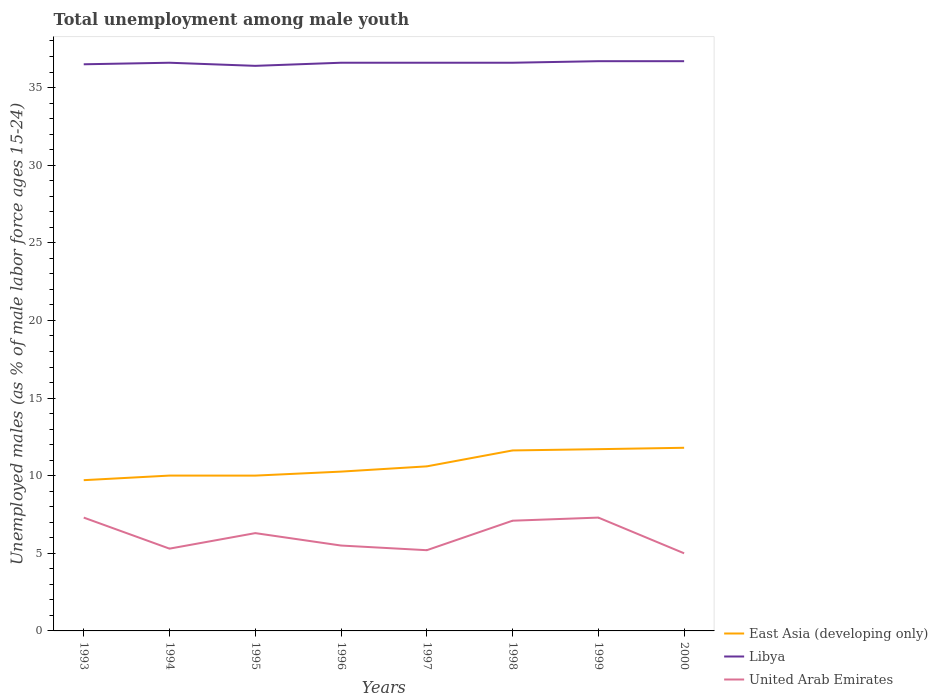Across all years, what is the maximum percentage of unemployed males in in United Arab Emirates?
Your answer should be very brief. 5. In which year was the percentage of unemployed males in in Libya maximum?
Keep it short and to the point. 1995. What is the total percentage of unemployed males in in East Asia (developing only) in the graph?
Ensure brevity in your answer.  -0.3. What is the difference between the highest and the second highest percentage of unemployed males in in United Arab Emirates?
Keep it short and to the point. 2.3. What is the difference between the highest and the lowest percentage of unemployed males in in United Arab Emirates?
Your answer should be compact. 4. Is the percentage of unemployed males in in United Arab Emirates strictly greater than the percentage of unemployed males in in East Asia (developing only) over the years?
Provide a short and direct response. Yes. How many lines are there?
Give a very brief answer. 3. How many years are there in the graph?
Provide a short and direct response. 8. Does the graph contain any zero values?
Provide a succinct answer. No. Does the graph contain grids?
Provide a succinct answer. No. How are the legend labels stacked?
Make the answer very short. Vertical. What is the title of the graph?
Give a very brief answer. Total unemployment among male youth. What is the label or title of the X-axis?
Your answer should be compact. Years. What is the label or title of the Y-axis?
Keep it short and to the point. Unemployed males (as % of male labor force ages 15-24). What is the Unemployed males (as % of male labor force ages 15-24) in East Asia (developing only) in 1993?
Keep it short and to the point. 9.71. What is the Unemployed males (as % of male labor force ages 15-24) in Libya in 1993?
Provide a short and direct response. 36.5. What is the Unemployed males (as % of male labor force ages 15-24) in United Arab Emirates in 1993?
Your answer should be very brief. 7.3. What is the Unemployed males (as % of male labor force ages 15-24) in East Asia (developing only) in 1994?
Give a very brief answer. 10.01. What is the Unemployed males (as % of male labor force ages 15-24) of Libya in 1994?
Offer a terse response. 36.6. What is the Unemployed males (as % of male labor force ages 15-24) in United Arab Emirates in 1994?
Offer a very short reply. 5.3. What is the Unemployed males (as % of male labor force ages 15-24) in East Asia (developing only) in 1995?
Provide a short and direct response. 10. What is the Unemployed males (as % of male labor force ages 15-24) in Libya in 1995?
Your answer should be very brief. 36.4. What is the Unemployed males (as % of male labor force ages 15-24) in United Arab Emirates in 1995?
Make the answer very short. 6.3. What is the Unemployed males (as % of male labor force ages 15-24) in East Asia (developing only) in 1996?
Your answer should be very brief. 10.26. What is the Unemployed males (as % of male labor force ages 15-24) in Libya in 1996?
Ensure brevity in your answer.  36.6. What is the Unemployed males (as % of male labor force ages 15-24) in United Arab Emirates in 1996?
Give a very brief answer. 5.5. What is the Unemployed males (as % of male labor force ages 15-24) of East Asia (developing only) in 1997?
Your response must be concise. 10.6. What is the Unemployed males (as % of male labor force ages 15-24) in Libya in 1997?
Keep it short and to the point. 36.6. What is the Unemployed males (as % of male labor force ages 15-24) in United Arab Emirates in 1997?
Offer a very short reply. 5.2. What is the Unemployed males (as % of male labor force ages 15-24) in East Asia (developing only) in 1998?
Provide a succinct answer. 11.63. What is the Unemployed males (as % of male labor force ages 15-24) of Libya in 1998?
Offer a very short reply. 36.6. What is the Unemployed males (as % of male labor force ages 15-24) in United Arab Emirates in 1998?
Offer a very short reply. 7.1. What is the Unemployed males (as % of male labor force ages 15-24) of East Asia (developing only) in 1999?
Ensure brevity in your answer.  11.71. What is the Unemployed males (as % of male labor force ages 15-24) in Libya in 1999?
Offer a terse response. 36.7. What is the Unemployed males (as % of male labor force ages 15-24) in United Arab Emirates in 1999?
Offer a terse response. 7.3. What is the Unemployed males (as % of male labor force ages 15-24) in East Asia (developing only) in 2000?
Give a very brief answer. 11.8. What is the Unemployed males (as % of male labor force ages 15-24) in Libya in 2000?
Give a very brief answer. 36.7. Across all years, what is the maximum Unemployed males (as % of male labor force ages 15-24) in East Asia (developing only)?
Ensure brevity in your answer.  11.8. Across all years, what is the maximum Unemployed males (as % of male labor force ages 15-24) in Libya?
Your response must be concise. 36.7. Across all years, what is the maximum Unemployed males (as % of male labor force ages 15-24) of United Arab Emirates?
Offer a very short reply. 7.3. Across all years, what is the minimum Unemployed males (as % of male labor force ages 15-24) in East Asia (developing only)?
Give a very brief answer. 9.71. Across all years, what is the minimum Unemployed males (as % of male labor force ages 15-24) of Libya?
Ensure brevity in your answer.  36.4. What is the total Unemployed males (as % of male labor force ages 15-24) in East Asia (developing only) in the graph?
Offer a terse response. 85.71. What is the total Unemployed males (as % of male labor force ages 15-24) in Libya in the graph?
Make the answer very short. 292.7. What is the difference between the Unemployed males (as % of male labor force ages 15-24) in East Asia (developing only) in 1993 and that in 1994?
Give a very brief answer. -0.3. What is the difference between the Unemployed males (as % of male labor force ages 15-24) in United Arab Emirates in 1993 and that in 1994?
Your response must be concise. 2. What is the difference between the Unemployed males (as % of male labor force ages 15-24) of East Asia (developing only) in 1993 and that in 1995?
Offer a very short reply. -0.29. What is the difference between the Unemployed males (as % of male labor force ages 15-24) in Libya in 1993 and that in 1995?
Keep it short and to the point. 0.1. What is the difference between the Unemployed males (as % of male labor force ages 15-24) of United Arab Emirates in 1993 and that in 1995?
Keep it short and to the point. 1. What is the difference between the Unemployed males (as % of male labor force ages 15-24) in East Asia (developing only) in 1993 and that in 1996?
Give a very brief answer. -0.55. What is the difference between the Unemployed males (as % of male labor force ages 15-24) of United Arab Emirates in 1993 and that in 1996?
Offer a very short reply. 1.8. What is the difference between the Unemployed males (as % of male labor force ages 15-24) in East Asia (developing only) in 1993 and that in 1997?
Offer a very short reply. -0.89. What is the difference between the Unemployed males (as % of male labor force ages 15-24) of Libya in 1993 and that in 1997?
Keep it short and to the point. -0.1. What is the difference between the Unemployed males (as % of male labor force ages 15-24) of East Asia (developing only) in 1993 and that in 1998?
Offer a terse response. -1.92. What is the difference between the Unemployed males (as % of male labor force ages 15-24) in Libya in 1993 and that in 1998?
Make the answer very short. -0.1. What is the difference between the Unemployed males (as % of male labor force ages 15-24) of East Asia (developing only) in 1993 and that in 1999?
Offer a very short reply. -2. What is the difference between the Unemployed males (as % of male labor force ages 15-24) of Libya in 1993 and that in 1999?
Offer a very short reply. -0.2. What is the difference between the Unemployed males (as % of male labor force ages 15-24) in United Arab Emirates in 1993 and that in 1999?
Provide a short and direct response. 0. What is the difference between the Unemployed males (as % of male labor force ages 15-24) in East Asia (developing only) in 1993 and that in 2000?
Keep it short and to the point. -2.09. What is the difference between the Unemployed males (as % of male labor force ages 15-24) of Libya in 1993 and that in 2000?
Make the answer very short. -0.2. What is the difference between the Unemployed males (as % of male labor force ages 15-24) of East Asia (developing only) in 1994 and that in 1995?
Make the answer very short. 0. What is the difference between the Unemployed males (as % of male labor force ages 15-24) of Libya in 1994 and that in 1995?
Offer a terse response. 0.2. What is the difference between the Unemployed males (as % of male labor force ages 15-24) of East Asia (developing only) in 1994 and that in 1996?
Your answer should be compact. -0.26. What is the difference between the Unemployed males (as % of male labor force ages 15-24) in Libya in 1994 and that in 1996?
Provide a succinct answer. 0. What is the difference between the Unemployed males (as % of male labor force ages 15-24) of United Arab Emirates in 1994 and that in 1996?
Offer a very short reply. -0.2. What is the difference between the Unemployed males (as % of male labor force ages 15-24) in East Asia (developing only) in 1994 and that in 1997?
Keep it short and to the point. -0.59. What is the difference between the Unemployed males (as % of male labor force ages 15-24) in Libya in 1994 and that in 1997?
Ensure brevity in your answer.  0. What is the difference between the Unemployed males (as % of male labor force ages 15-24) in East Asia (developing only) in 1994 and that in 1998?
Provide a short and direct response. -1.62. What is the difference between the Unemployed males (as % of male labor force ages 15-24) in East Asia (developing only) in 1994 and that in 1999?
Provide a short and direct response. -1.7. What is the difference between the Unemployed males (as % of male labor force ages 15-24) of Libya in 1994 and that in 1999?
Provide a succinct answer. -0.1. What is the difference between the Unemployed males (as % of male labor force ages 15-24) of United Arab Emirates in 1994 and that in 1999?
Provide a short and direct response. -2. What is the difference between the Unemployed males (as % of male labor force ages 15-24) of East Asia (developing only) in 1994 and that in 2000?
Provide a succinct answer. -1.79. What is the difference between the Unemployed males (as % of male labor force ages 15-24) in Libya in 1994 and that in 2000?
Give a very brief answer. -0.1. What is the difference between the Unemployed males (as % of male labor force ages 15-24) in East Asia (developing only) in 1995 and that in 1996?
Give a very brief answer. -0.26. What is the difference between the Unemployed males (as % of male labor force ages 15-24) of Libya in 1995 and that in 1996?
Offer a terse response. -0.2. What is the difference between the Unemployed males (as % of male labor force ages 15-24) of United Arab Emirates in 1995 and that in 1996?
Give a very brief answer. 0.8. What is the difference between the Unemployed males (as % of male labor force ages 15-24) in East Asia (developing only) in 1995 and that in 1997?
Provide a short and direct response. -0.6. What is the difference between the Unemployed males (as % of male labor force ages 15-24) of Libya in 1995 and that in 1997?
Your answer should be very brief. -0.2. What is the difference between the Unemployed males (as % of male labor force ages 15-24) in United Arab Emirates in 1995 and that in 1997?
Provide a succinct answer. 1.1. What is the difference between the Unemployed males (as % of male labor force ages 15-24) in East Asia (developing only) in 1995 and that in 1998?
Offer a very short reply. -1.62. What is the difference between the Unemployed males (as % of male labor force ages 15-24) of Libya in 1995 and that in 1998?
Offer a very short reply. -0.2. What is the difference between the Unemployed males (as % of male labor force ages 15-24) in United Arab Emirates in 1995 and that in 1998?
Provide a succinct answer. -0.8. What is the difference between the Unemployed males (as % of male labor force ages 15-24) of East Asia (developing only) in 1995 and that in 1999?
Make the answer very short. -1.7. What is the difference between the Unemployed males (as % of male labor force ages 15-24) of United Arab Emirates in 1995 and that in 1999?
Offer a very short reply. -1. What is the difference between the Unemployed males (as % of male labor force ages 15-24) of East Asia (developing only) in 1995 and that in 2000?
Offer a very short reply. -1.79. What is the difference between the Unemployed males (as % of male labor force ages 15-24) in Libya in 1995 and that in 2000?
Your answer should be compact. -0.3. What is the difference between the Unemployed males (as % of male labor force ages 15-24) of East Asia (developing only) in 1996 and that in 1997?
Ensure brevity in your answer.  -0.34. What is the difference between the Unemployed males (as % of male labor force ages 15-24) in Libya in 1996 and that in 1997?
Offer a terse response. 0. What is the difference between the Unemployed males (as % of male labor force ages 15-24) in East Asia (developing only) in 1996 and that in 1998?
Keep it short and to the point. -1.36. What is the difference between the Unemployed males (as % of male labor force ages 15-24) of Libya in 1996 and that in 1998?
Your response must be concise. 0. What is the difference between the Unemployed males (as % of male labor force ages 15-24) of United Arab Emirates in 1996 and that in 1998?
Keep it short and to the point. -1.6. What is the difference between the Unemployed males (as % of male labor force ages 15-24) in East Asia (developing only) in 1996 and that in 1999?
Your answer should be very brief. -1.44. What is the difference between the Unemployed males (as % of male labor force ages 15-24) of Libya in 1996 and that in 1999?
Your response must be concise. -0.1. What is the difference between the Unemployed males (as % of male labor force ages 15-24) of United Arab Emirates in 1996 and that in 1999?
Offer a terse response. -1.8. What is the difference between the Unemployed males (as % of male labor force ages 15-24) of East Asia (developing only) in 1996 and that in 2000?
Give a very brief answer. -1.53. What is the difference between the Unemployed males (as % of male labor force ages 15-24) in Libya in 1996 and that in 2000?
Your response must be concise. -0.1. What is the difference between the Unemployed males (as % of male labor force ages 15-24) of United Arab Emirates in 1996 and that in 2000?
Offer a terse response. 0.5. What is the difference between the Unemployed males (as % of male labor force ages 15-24) of East Asia (developing only) in 1997 and that in 1998?
Keep it short and to the point. -1.03. What is the difference between the Unemployed males (as % of male labor force ages 15-24) of East Asia (developing only) in 1997 and that in 1999?
Keep it short and to the point. -1.11. What is the difference between the Unemployed males (as % of male labor force ages 15-24) of Libya in 1997 and that in 1999?
Provide a succinct answer. -0.1. What is the difference between the Unemployed males (as % of male labor force ages 15-24) in East Asia (developing only) in 1997 and that in 2000?
Keep it short and to the point. -1.2. What is the difference between the Unemployed males (as % of male labor force ages 15-24) in East Asia (developing only) in 1998 and that in 1999?
Offer a terse response. -0.08. What is the difference between the Unemployed males (as % of male labor force ages 15-24) of East Asia (developing only) in 1998 and that in 2000?
Give a very brief answer. -0.17. What is the difference between the Unemployed males (as % of male labor force ages 15-24) in East Asia (developing only) in 1999 and that in 2000?
Your answer should be compact. -0.09. What is the difference between the Unemployed males (as % of male labor force ages 15-24) in Libya in 1999 and that in 2000?
Offer a very short reply. 0. What is the difference between the Unemployed males (as % of male labor force ages 15-24) in East Asia (developing only) in 1993 and the Unemployed males (as % of male labor force ages 15-24) in Libya in 1994?
Offer a terse response. -26.89. What is the difference between the Unemployed males (as % of male labor force ages 15-24) in East Asia (developing only) in 1993 and the Unemployed males (as % of male labor force ages 15-24) in United Arab Emirates in 1994?
Provide a short and direct response. 4.41. What is the difference between the Unemployed males (as % of male labor force ages 15-24) in Libya in 1993 and the Unemployed males (as % of male labor force ages 15-24) in United Arab Emirates in 1994?
Offer a very short reply. 31.2. What is the difference between the Unemployed males (as % of male labor force ages 15-24) of East Asia (developing only) in 1993 and the Unemployed males (as % of male labor force ages 15-24) of Libya in 1995?
Provide a short and direct response. -26.69. What is the difference between the Unemployed males (as % of male labor force ages 15-24) in East Asia (developing only) in 1993 and the Unemployed males (as % of male labor force ages 15-24) in United Arab Emirates in 1995?
Your answer should be compact. 3.41. What is the difference between the Unemployed males (as % of male labor force ages 15-24) in Libya in 1993 and the Unemployed males (as % of male labor force ages 15-24) in United Arab Emirates in 1995?
Your answer should be very brief. 30.2. What is the difference between the Unemployed males (as % of male labor force ages 15-24) in East Asia (developing only) in 1993 and the Unemployed males (as % of male labor force ages 15-24) in Libya in 1996?
Your answer should be very brief. -26.89. What is the difference between the Unemployed males (as % of male labor force ages 15-24) of East Asia (developing only) in 1993 and the Unemployed males (as % of male labor force ages 15-24) of United Arab Emirates in 1996?
Offer a very short reply. 4.21. What is the difference between the Unemployed males (as % of male labor force ages 15-24) in East Asia (developing only) in 1993 and the Unemployed males (as % of male labor force ages 15-24) in Libya in 1997?
Your answer should be very brief. -26.89. What is the difference between the Unemployed males (as % of male labor force ages 15-24) of East Asia (developing only) in 1993 and the Unemployed males (as % of male labor force ages 15-24) of United Arab Emirates in 1997?
Ensure brevity in your answer.  4.51. What is the difference between the Unemployed males (as % of male labor force ages 15-24) in Libya in 1993 and the Unemployed males (as % of male labor force ages 15-24) in United Arab Emirates in 1997?
Offer a very short reply. 31.3. What is the difference between the Unemployed males (as % of male labor force ages 15-24) of East Asia (developing only) in 1993 and the Unemployed males (as % of male labor force ages 15-24) of Libya in 1998?
Ensure brevity in your answer.  -26.89. What is the difference between the Unemployed males (as % of male labor force ages 15-24) of East Asia (developing only) in 1993 and the Unemployed males (as % of male labor force ages 15-24) of United Arab Emirates in 1998?
Provide a short and direct response. 2.61. What is the difference between the Unemployed males (as % of male labor force ages 15-24) in Libya in 1993 and the Unemployed males (as % of male labor force ages 15-24) in United Arab Emirates in 1998?
Your answer should be very brief. 29.4. What is the difference between the Unemployed males (as % of male labor force ages 15-24) in East Asia (developing only) in 1993 and the Unemployed males (as % of male labor force ages 15-24) in Libya in 1999?
Keep it short and to the point. -26.99. What is the difference between the Unemployed males (as % of male labor force ages 15-24) of East Asia (developing only) in 1993 and the Unemployed males (as % of male labor force ages 15-24) of United Arab Emirates in 1999?
Ensure brevity in your answer.  2.41. What is the difference between the Unemployed males (as % of male labor force ages 15-24) in Libya in 1993 and the Unemployed males (as % of male labor force ages 15-24) in United Arab Emirates in 1999?
Make the answer very short. 29.2. What is the difference between the Unemployed males (as % of male labor force ages 15-24) of East Asia (developing only) in 1993 and the Unemployed males (as % of male labor force ages 15-24) of Libya in 2000?
Keep it short and to the point. -26.99. What is the difference between the Unemployed males (as % of male labor force ages 15-24) in East Asia (developing only) in 1993 and the Unemployed males (as % of male labor force ages 15-24) in United Arab Emirates in 2000?
Give a very brief answer. 4.71. What is the difference between the Unemployed males (as % of male labor force ages 15-24) in Libya in 1993 and the Unemployed males (as % of male labor force ages 15-24) in United Arab Emirates in 2000?
Make the answer very short. 31.5. What is the difference between the Unemployed males (as % of male labor force ages 15-24) in East Asia (developing only) in 1994 and the Unemployed males (as % of male labor force ages 15-24) in Libya in 1995?
Offer a very short reply. -26.39. What is the difference between the Unemployed males (as % of male labor force ages 15-24) in East Asia (developing only) in 1994 and the Unemployed males (as % of male labor force ages 15-24) in United Arab Emirates in 1995?
Make the answer very short. 3.71. What is the difference between the Unemployed males (as % of male labor force ages 15-24) in Libya in 1994 and the Unemployed males (as % of male labor force ages 15-24) in United Arab Emirates in 1995?
Provide a succinct answer. 30.3. What is the difference between the Unemployed males (as % of male labor force ages 15-24) in East Asia (developing only) in 1994 and the Unemployed males (as % of male labor force ages 15-24) in Libya in 1996?
Your answer should be very brief. -26.59. What is the difference between the Unemployed males (as % of male labor force ages 15-24) of East Asia (developing only) in 1994 and the Unemployed males (as % of male labor force ages 15-24) of United Arab Emirates in 1996?
Offer a very short reply. 4.51. What is the difference between the Unemployed males (as % of male labor force ages 15-24) in Libya in 1994 and the Unemployed males (as % of male labor force ages 15-24) in United Arab Emirates in 1996?
Make the answer very short. 31.1. What is the difference between the Unemployed males (as % of male labor force ages 15-24) of East Asia (developing only) in 1994 and the Unemployed males (as % of male labor force ages 15-24) of Libya in 1997?
Provide a short and direct response. -26.59. What is the difference between the Unemployed males (as % of male labor force ages 15-24) in East Asia (developing only) in 1994 and the Unemployed males (as % of male labor force ages 15-24) in United Arab Emirates in 1997?
Offer a terse response. 4.81. What is the difference between the Unemployed males (as % of male labor force ages 15-24) in Libya in 1994 and the Unemployed males (as % of male labor force ages 15-24) in United Arab Emirates in 1997?
Give a very brief answer. 31.4. What is the difference between the Unemployed males (as % of male labor force ages 15-24) in East Asia (developing only) in 1994 and the Unemployed males (as % of male labor force ages 15-24) in Libya in 1998?
Provide a short and direct response. -26.59. What is the difference between the Unemployed males (as % of male labor force ages 15-24) in East Asia (developing only) in 1994 and the Unemployed males (as % of male labor force ages 15-24) in United Arab Emirates in 1998?
Your answer should be very brief. 2.91. What is the difference between the Unemployed males (as % of male labor force ages 15-24) of Libya in 1994 and the Unemployed males (as % of male labor force ages 15-24) of United Arab Emirates in 1998?
Provide a succinct answer. 29.5. What is the difference between the Unemployed males (as % of male labor force ages 15-24) in East Asia (developing only) in 1994 and the Unemployed males (as % of male labor force ages 15-24) in Libya in 1999?
Your answer should be very brief. -26.69. What is the difference between the Unemployed males (as % of male labor force ages 15-24) in East Asia (developing only) in 1994 and the Unemployed males (as % of male labor force ages 15-24) in United Arab Emirates in 1999?
Make the answer very short. 2.71. What is the difference between the Unemployed males (as % of male labor force ages 15-24) in Libya in 1994 and the Unemployed males (as % of male labor force ages 15-24) in United Arab Emirates in 1999?
Offer a terse response. 29.3. What is the difference between the Unemployed males (as % of male labor force ages 15-24) of East Asia (developing only) in 1994 and the Unemployed males (as % of male labor force ages 15-24) of Libya in 2000?
Offer a terse response. -26.69. What is the difference between the Unemployed males (as % of male labor force ages 15-24) of East Asia (developing only) in 1994 and the Unemployed males (as % of male labor force ages 15-24) of United Arab Emirates in 2000?
Offer a terse response. 5.01. What is the difference between the Unemployed males (as % of male labor force ages 15-24) of Libya in 1994 and the Unemployed males (as % of male labor force ages 15-24) of United Arab Emirates in 2000?
Ensure brevity in your answer.  31.6. What is the difference between the Unemployed males (as % of male labor force ages 15-24) of East Asia (developing only) in 1995 and the Unemployed males (as % of male labor force ages 15-24) of Libya in 1996?
Give a very brief answer. -26.6. What is the difference between the Unemployed males (as % of male labor force ages 15-24) in East Asia (developing only) in 1995 and the Unemployed males (as % of male labor force ages 15-24) in United Arab Emirates in 1996?
Keep it short and to the point. 4.5. What is the difference between the Unemployed males (as % of male labor force ages 15-24) in Libya in 1995 and the Unemployed males (as % of male labor force ages 15-24) in United Arab Emirates in 1996?
Ensure brevity in your answer.  30.9. What is the difference between the Unemployed males (as % of male labor force ages 15-24) in East Asia (developing only) in 1995 and the Unemployed males (as % of male labor force ages 15-24) in Libya in 1997?
Offer a terse response. -26.6. What is the difference between the Unemployed males (as % of male labor force ages 15-24) in East Asia (developing only) in 1995 and the Unemployed males (as % of male labor force ages 15-24) in United Arab Emirates in 1997?
Your answer should be very brief. 4.8. What is the difference between the Unemployed males (as % of male labor force ages 15-24) in Libya in 1995 and the Unemployed males (as % of male labor force ages 15-24) in United Arab Emirates in 1997?
Your response must be concise. 31.2. What is the difference between the Unemployed males (as % of male labor force ages 15-24) in East Asia (developing only) in 1995 and the Unemployed males (as % of male labor force ages 15-24) in Libya in 1998?
Give a very brief answer. -26.6. What is the difference between the Unemployed males (as % of male labor force ages 15-24) in East Asia (developing only) in 1995 and the Unemployed males (as % of male labor force ages 15-24) in United Arab Emirates in 1998?
Make the answer very short. 2.9. What is the difference between the Unemployed males (as % of male labor force ages 15-24) of Libya in 1995 and the Unemployed males (as % of male labor force ages 15-24) of United Arab Emirates in 1998?
Your answer should be very brief. 29.3. What is the difference between the Unemployed males (as % of male labor force ages 15-24) in East Asia (developing only) in 1995 and the Unemployed males (as % of male labor force ages 15-24) in Libya in 1999?
Your answer should be very brief. -26.7. What is the difference between the Unemployed males (as % of male labor force ages 15-24) in East Asia (developing only) in 1995 and the Unemployed males (as % of male labor force ages 15-24) in United Arab Emirates in 1999?
Your answer should be compact. 2.7. What is the difference between the Unemployed males (as % of male labor force ages 15-24) in Libya in 1995 and the Unemployed males (as % of male labor force ages 15-24) in United Arab Emirates in 1999?
Your answer should be compact. 29.1. What is the difference between the Unemployed males (as % of male labor force ages 15-24) of East Asia (developing only) in 1995 and the Unemployed males (as % of male labor force ages 15-24) of Libya in 2000?
Your response must be concise. -26.7. What is the difference between the Unemployed males (as % of male labor force ages 15-24) of East Asia (developing only) in 1995 and the Unemployed males (as % of male labor force ages 15-24) of United Arab Emirates in 2000?
Provide a short and direct response. 5. What is the difference between the Unemployed males (as % of male labor force ages 15-24) of Libya in 1995 and the Unemployed males (as % of male labor force ages 15-24) of United Arab Emirates in 2000?
Keep it short and to the point. 31.4. What is the difference between the Unemployed males (as % of male labor force ages 15-24) in East Asia (developing only) in 1996 and the Unemployed males (as % of male labor force ages 15-24) in Libya in 1997?
Your answer should be compact. -26.34. What is the difference between the Unemployed males (as % of male labor force ages 15-24) of East Asia (developing only) in 1996 and the Unemployed males (as % of male labor force ages 15-24) of United Arab Emirates in 1997?
Offer a terse response. 5.06. What is the difference between the Unemployed males (as % of male labor force ages 15-24) of Libya in 1996 and the Unemployed males (as % of male labor force ages 15-24) of United Arab Emirates in 1997?
Your answer should be very brief. 31.4. What is the difference between the Unemployed males (as % of male labor force ages 15-24) of East Asia (developing only) in 1996 and the Unemployed males (as % of male labor force ages 15-24) of Libya in 1998?
Your answer should be compact. -26.34. What is the difference between the Unemployed males (as % of male labor force ages 15-24) in East Asia (developing only) in 1996 and the Unemployed males (as % of male labor force ages 15-24) in United Arab Emirates in 1998?
Your answer should be very brief. 3.16. What is the difference between the Unemployed males (as % of male labor force ages 15-24) in Libya in 1996 and the Unemployed males (as % of male labor force ages 15-24) in United Arab Emirates in 1998?
Offer a very short reply. 29.5. What is the difference between the Unemployed males (as % of male labor force ages 15-24) in East Asia (developing only) in 1996 and the Unemployed males (as % of male labor force ages 15-24) in Libya in 1999?
Offer a terse response. -26.44. What is the difference between the Unemployed males (as % of male labor force ages 15-24) of East Asia (developing only) in 1996 and the Unemployed males (as % of male labor force ages 15-24) of United Arab Emirates in 1999?
Make the answer very short. 2.96. What is the difference between the Unemployed males (as % of male labor force ages 15-24) of Libya in 1996 and the Unemployed males (as % of male labor force ages 15-24) of United Arab Emirates in 1999?
Give a very brief answer. 29.3. What is the difference between the Unemployed males (as % of male labor force ages 15-24) of East Asia (developing only) in 1996 and the Unemployed males (as % of male labor force ages 15-24) of Libya in 2000?
Offer a very short reply. -26.44. What is the difference between the Unemployed males (as % of male labor force ages 15-24) of East Asia (developing only) in 1996 and the Unemployed males (as % of male labor force ages 15-24) of United Arab Emirates in 2000?
Keep it short and to the point. 5.26. What is the difference between the Unemployed males (as % of male labor force ages 15-24) in Libya in 1996 and the Unemployed males (as % of male labor force ages 15-24) in United Arab Emirates in 2000?
Offer a very short reply. 31.6. What is the difference between the Unemployed males (as % of male labor force ages 15-24) in East Asia (developing only) in 1997 and the Unemployed males (as % of male labor force ages 15-24) in Libya in 1998?
Give a very brief answer. -26. What is the difference between the Unemployed males (as % of male labor force ages 15-24) of East Asia (developing only) in 1997 and the Unemployed males (as % of male labor force ages 15-24) of United Arab Emirates in 1998?
Provide a succinct answer. 3.5. What is the difference between the Unemployed males (as % of male labor force ages 15-24) of Libya in 1997 and the Unemployed males (as % of male labor force ages 15-24) of United Arab Emirates in 1998?
Provide a succinct answer. 29.5. What is the difference between the Unemployed males (as % of male labor force ages 15-24) of East Asia (developing only) in 1997 and the Unemployed males (as % of male labor force ages 15-24) of Libya in 1999?
Offer a very short reply. -26.1. What is the difference between the Unemployed males (as % of male labor force ages 15-24) in East Asia (developing only) in 1997 and the Unemployed males (as % of male labor force ages 15-24) in United Arab Emirates in 1999?
Your answer should be compact. 3.3. What is the difference between the Unemployed males (as % of male labor force ages 15-24) of Libya in 1997 and the Unemployed males (as % of male labor force ages 15-24) of United Arab Emirates in 1999?
Your answer should be compact. 29.3. What is the difference between the Unemployed males (as % of male labor force ages 15-24) in East Asia (developing only) in 1997 and the Unemployed males (as % of male labor force ages 15-24) in Libya in 2000?
Provide a succinct answer. -26.1. What is the difference between the Unemployed males (as % of male labor force ages 15-24) of East Asia (developing only) in 1997 and the Unemployed males (as % of male labor force ages 15-24) of United Arab Emirates in 2000?
Offer a terse response. 5.6. What is the difference between the Unemployed males (as % of male labor force ages 15-24) of Libya in 1997 and the Unemployed males (as % of male labor force ages 15-24) of United Arab Emirates in 2000?
Offer a very short reply. 31.6. What is the difference between the Unemployed males (as % of male labor force ages 15-24) in East Asia (developing only) in 1998 and the Unemployed males (as % of male labor force ages 15-24) in Libya in 1999?
Provide a short and direct response. -25.07. What is the difference between the Unemployed males (as % of male labor force ages 15-24) of East Asia (developing only) in 1998 and the Unemployed males (as % of male labor force ages 15-24) of United Arab Emirates in 1999?
Keep it short and to the point. 4.33. What is the difference between the Unemployed males (as % of male labor force ages 15-24) of Libya in 1998 and the Unemployed males (as % of male labor force ages 15-24) of United Arab Emirates in 1999?
Provide a short and direct response. 29.3. What is the difference between the Unemployed males (as % of male labor force ages 15-24) in East Asia (developing only) in 1998 and the Unemployed males (as % of male labor force ages 15-24) in Libya in 2000?
Ensure brevity in your answer.  -25.07. What is the difference between the Unemployed males (as % of male labor force ages 15-24) in East Asia (developing only) in 1998 and the Unemployed males (as % of male labor force ages 15-24) in United Arab Emirates in 2000?
Your answer should be very brief. 6.63. What is the difference between the Unemployed males (as % of male labor force ages 15-24) in Libya in 1998 and the Unemployed males (as % of male labor force ages 15-24) in United Arab Emirates in 2000?
Your answer should be very brief. 31.6. What is the difference between the Unemployed males (as % of male labor force ages 15-24) of East Asia (developing only) in 1999 and the Unemployed males (as % of male labor force ages 15-24) of Libya in 2000?
Provide a succinct answer. -24.99. What is the difference between the Unemployed males (as % of male labor force ages 15-24) in East Asia (developing only) in 1999 and the Unemployed males (as % of male labor force ages 15-24) in United Arab Emirates in 2000?
Keep it short and to the point. 6.71. What is the difference between the Unemployed males (as % of male labor force ages 15-24) of Libya in 1999 and the Unemployed males (as % of male labor force ages 15-24) of United Arab Emirates in 2000?
Your answer should be compact. 31.7. What is the average Unemployed males (as % of male labor force ages 15-24) of East Asia (developing only) per year?
Your answer should be very brief. 10.71. What is the average Unemployed males (as % of male labor force ages 15-24) of Libya per year?
Your answer should be very brief. 36.59. What is the average Unemployed males (as % of male labor force ages 15-24) of United Arab Emirates per year?
Provide a short and direct response. 6.12. In the year 1993, what is the difference between the Unemployed males (as % of male labor force ages 15-24) of East Asia (developing only) and Unemployed males (as % of male labor force ages 15-24) of Libya?
Your response must be concise. -26.79. In the year 1993, what is the difference between the Unemployed males (as % of male labor force ages 15-24) of East Asia (developing only) and Unemployed males (as % of male labor force ages 15-24) of United Arab Emirates?
Ensure brevity in your answer.  2.41. In the year 1993, what is the difference between the Unemployed males (as % of male labor force ages 15-24) in Libya and Unemployed males (as % of male labor force ages 15-24) in United Arab Emirates?
Your response must be concise. 29.2. In the year 1994, what is the difference between the Unemployed males (as % of male labor force ages 15-24) of East Asia (developing only) and Unemployed males (as % of male labor force ages 15-24) of Libya?
Your answer should be compact. -26.59. In the year 1994, what is the difference between the Unemployed males (as % of male labor force ages 15-24) in East Asia (developing only) and Unemployed males (as % of male labor force ages 15-24) in United Arab Emirates?
Ensure brevity in your answer.  4.71. In the year 1994, what is the difference between the Unemployed males (as % of male labor force ages 15-24) in Libya and Unemployed males (as % of male labor force ages 15-24) in United Arab Emirates?
Offer a terse response. 31.3. In the year 1995, what is the difference between the Unemployed males (as % of male labor force ages 15-24) in East Asia (developing only) and Unemployed males (as % of male labor force ages 15-24) in Libya?
Make the answer very short. -26.4. In the year 1995, what is the difference between the Unemployed males (as % of male labor force ages 15-24) in East Asia (developing only) and Unemployed males (as % of male labor force ages 15-24) in United Arab Emirates?
Offer a very short reply. 3.7. In the year 1995, what is the difference between the Unemployed males (as % of male labor force ages 15-24) in Libya and Unemployed males (as % of male labor force ages 15-24) in United Arab Emirates?
Offer a very short reply. 30.1. In the year 1996, what is the difference between the Unemployed males (as % of male labor force ages 15-24) in East Asia (developing only) and Unemployed males (as % of male labor force ages 15-24) in Libya?
Offer a very short reply. -26.34. In the year 1996, what is the difference between the Unemployed males (as % of male labor force ages 15-24) of East Asia (developing only) and Unemployed males (as % of male labor force ages 15-24) of United Arab Emirates?
Provide a short and direct response. 4.76. In the year 1996, what is the difference between the Unemployed males (as % of male labor force ages 15-24) in Libya and Unemployed males (as % of male labor force ages 15-24) in United Arab Emirates?
Offer a terse response. 31.1. In the year 1997, what is the difference between the Unemployed males (as % of male labor force ages 15-24) in East Asia (developing only) and Unemployed males (as % of male labor force ages 15-24) in Libya?
Make the answer very short. -26. In the year 1997, what is the difference between the Unemployed males (as % of male labor force ages 15-24) in East Asia (developing only) and Unemployed males (as % of male labor force ages 15-24) in United Arab Emirates?
Provide a short and direct response. 5.4. In the year 1997, what is the difference between the Unemployed males (as % of male labor force ages 15-24) in Libya and Unemployed males (as % of male labor force ages 15-24) in United Arab Emirates?
Ensure brevity in your answer.  31.4. In the year 1998, what is the difference between the Unemployed males (as % of male labor force ages 15-24) in East Asia (developing only) and Unemployed males (as % of male labor force ages 15-24) in Libya?
Your answer should be very brief. -24.97. In the year 1998, what is the difference between the Unemployed males (as % of male labor force ages 15-24) in East Asia (developing only) and Unemployed males (as % of male labor force ages 15-24) in United Arab Emirates?
Provide a succinct answer. 4.53. In the year 1998, what is the difference between the Unemployed males (as % of male labor force ages 15-24) in Libya and Unemployed males (as % of male labor force ages 15-24) in United Arab Emirates?
Your response must be concise. 29.5. In the year 1999, what is the difference between the Unemployed males (as % of male labor force ages 15-24) in East Asia (developing only) and Unemployed males (as % of male labor force ages 15-24) in Libya?
Your answer should be compact. -24.99. In the year 1999, what is the difference between the Unemployed males (as % of male labor force ages 15-24) of East Asia (developing only) and Unemployed males (as % of male labor force ages 15-24) of United Arab Emirates?
Your answer should be very brief. 4.41. In the year 1999, what is the difference between the Unemployed males (as % of male labor force ages 15-24) of Libya and Unemployed males (as % of male labor force ages 15-24) of United Arab Emirates?
Provide a succinct answer. 29.4. In the year 2000, what is the difference between the Unemployed males (as % of male labor force ages 15-24) in East Asia (developing only) and Unemployed males (as % of male labor force ages 15-24) in Libya?
Make the answer very short. -24.9. In the year 2000, what is the difference between the Unemployed males (as % of male labor force ages 15-24) in East Asia (developing only) and Unemployed males (as % of male labor force ages 15-24) in United Arab Emirates?
Your response must be concise. 6.8. In the year 2000, what is the difference between the Unemployed males (as % of male labor force ages 15-24) of Libya and Unemployed males (as % of male labor force ages 15-24) of United Arab Emirates?
Offer a very short reply. 31.7. What is the ratio of the Unemployed males (as % of male labor force ages 15-24) of East Asia (developing only) in 1993 to that in 1994?
Provide a succinct answer. 0.97. What is the ratio of the Unemployed males (as % of male labor force ages 15-24) of United Arab Emirates in 1993 to that in 1994?
Give a very brief answer. 1.38. What is the ratio of the Unemployed males (as % of male labor force ages 15-24) in East Asia (developing only) in 1993 to that in 1995?
Ensure brevity in your answer.  0.97. What is the ratio of the Unemployed males (as % of male labor force ages 15-24) of United Arab Emirates in 1993 to that in 1995?
Provide a succinct answer. 1.16. What is the ratio of the Unemployed males (as % of male labor force ages 15-24) of East Asia (developing only) in 1993 to that in 1996?
Your answer should be very brief. 0.95. What is the ratio of the Unemployed males (as % of male labor force ages 15-24) of United Arab Emirates in 1993 to that in 1996?
Provide a succinct answer. 1.33. What is the ratio of the Unemployed males (as % of male labor force ages 15-24) in East Asia (developing only) in 1993 to that in 1997?
Your response must be concise. 0.92. What is the ratio of the Unemployed males (as % of male labor force ages 15-24) in United Arab Emirates in 1993 to that in 1997?
Offer a terse response. 1.4. What is the ratio of the Unemployed males (as % of male labor force ages 15-24) in East Asia (developing only) in 1993 to that in 1998?
Offer a terse response. 0.84. What is the ratio of the Unemployed males (as % of male labor force ages 15-24) in Libya in 1993 to that in 1998?
Give a very brief answer. 1. What is the ratio of the Unemployed males (as % of male labor force ages 15-24) in United Arab Emirates in 1993 to that in 1998?
Offer a very short reply. 1.03. What is the ratio of the Unemployed males (as % of male labor force ages 15-24) of East Asia (developing only) in 1993 to that in 1999?
Your response must be concise. 0.83. What is the ratio of the Unemployed males (as % of male labor force ages 15-24) in Libya in 1993 to that in 1999?
Provide a short and direct response. 0.99. What is the ratio of the Unemployed males (as % of male labor force ages 15-24) in East Asia (developing only) in 1993 to that in 2000?
Provide a short and direct response. 0.82. What is the ratio of the Unemployed males (as % of male labor force ages 15-24) in United Arab Emirates in 1993 to that in 2000?
Ensure brevity in your answer.  1.46. What is the ratio of the Unemployed males (as % of male labor force ages 15-24) of Libya in 1994 to that in 1995?
Offer a very short reply. 1.01. What is the ratio of the Unemployed males (as % of male labor force ages 15-24) of United Arab Emirates in 1994 to that in 1995?
Offer a terse response. 0.84. What is the ratio of the Unemployed males (as % of male labor force ages 15-24) of East Asia (developing only) in 1994 to that in 1996?
Your answer should be compact. 0.98. What is the ratio of the Unemployed males (as % of male labor force ages 15-24) in Libya in 1994 to that in 1996?
Give a very brief answer. 1. What is the ratio of the Unemployed males (as % of male labor force ages 15-24) of United Arab Emirates in 1994 to that in 1996?
Your answer should be compact. 0.96. What is the ratio of the Unemployed males (as % of male labor force ages 15-24) of East Asia (developing only) in 1994 to that in 1997?
Your answer should be compact. 0.94. What is the ratio of the Unemployed males (as % of male labor force ages 15-24) in Libya in 1994 to that in 1997?
Offer a very short reply. 1. What is the ratio of the Unemployed males (as % of male labor force ages 15-24) in United Arab Emirates in 1994 to that in 1997?
Your answer should be compact. 1.02. What is the ratio of the Unemployed males (as % of male labor force ages 15-24) in East Asia (developing only) in 1994 to that in 1998?
Make the answer very short. 0.86. What is the ratio of the Unemployed males (as % of male labor force ages 15-24) in United Arab Emirates in 1994 to that in 1998?
Provide a short and direct response. 0.75. What is the ratio of the Unemployed males (as % of male labor force ages 15-24) in East Asia (developing only) in 1994 to that in 1999?
Offer a very short reply. 0.85. What is the ratio of the Unemployed males (as % of male labor force ages 15-24) of Libya in 1994 to that in 1999?
Give a very brief answer. 1. What is the ratio of the Unemployed males (as % of male labor force ages 15-24) of United Arab Emirates in 1994 to that in 1999?
Make the answer very short. 0.73. What is the ratio of the Unemployed males (as % of male labor force ages 15-24) in East Asia (developing only) in 1994 to that in 2000?
Your response must be concise. 0.85. What is the ratio of the Unemployed males (as % of male labor force ages 15-24) in Libya in 1994 to that in 2000?
Give a very brief answer. 1. What is the ratio of the Unemployed males (as % of male labor force ages 15-24) of United Arab Emirates in 1994 to that in 2000?
Keep it short and to the point. 1.06. What is the ratio of the Unemployed males (as % of male labor force ages 15-24) of East Asia (developing only) in 1995 to that in 1996?
Your answer should be very brief. 0.97. What is the ratio of the Unemployed males (as % of male labor force ages 15-24) in United Arab Emirates in 1995 to that in 1996?
Your answer should be compact. 1.15. What is the ratio of the Unemployed males (as % of male labor force ages 15-24) of East Asia (developing only) in 1995 to that in 1997?
Your answer should be compact. 0.94. What is the ratio of the Unemployed males (as % of male labor force ages 15-24) in United Arab Emirates in 1995 to that in 1997?
Provide a succinct answer. 1.21. What is the ratio of the Unemployed males (as % of male labor force ages 15-24) in East Asia (developing only) in 1995 to that in 1998?
Keep it short and to the point. 0.86. What is the ratio of the Unemployed males (as % of male labor force ages 15-24) in United Arab Emirates in 1995 to that in 1998?
Your answer should be very brief. 0.89. What is the ratio of the Unemployed males (as % of male labor force ages 15-24) in East Asia (developing only) in 1995 to that in 1999?
Ensure brevity in your answer.  0.85. What is the ratio of the Unemployed males (as % of male labor force ages 15-24) in United Arab Emirates in 1995 to that in 1999?
Provide a succinct answer. 0.86. What is the ratio of the Unemployed males (as % of male labor force ages 15-24) in East Asia (developing only) in 1995 to that in 2000?
Provide a succinct answer. 0.85. What is the ratio of the Unemployed males (as % of male labor force ages 15-24) of Libya in 1995 to that in 2000?
Your answer should be compact. 0.99. What is the ratio of the Unemployed males (as % of male labor force ages 15-24) of United Arab Emirates in 1995 to that in 2000?
Keep it short and to the point. 1.26. What is the ratio of the Unemployed males (as % of male labor force ages 15-24) in East Asia (developing only) in 1996 to that in 1997?
Provide a succinct answer. 0.97. What is the ratio of the Unemployed males (as % of male labor force ages 15-24) of Libya in 1996 to that in 1997?
Your answer should be compact. 1. What is the ratio of the Unemployed males (as % of male labor force ages 15-24) in United Arab Emirates in 1996 to that in 1997?
Ensure brevity in your answer.  1.06. What is the ratio of the Unemployed males (as % of male labor force ages 15-24) of East Asia (developing only) in 1996 to that in 1998?
Keep it short and to the point. 0.88. What is the ratio of the Unemployed males (as % of male labor force ages 15-24) of Libya in 1996 to that in 1998?
Your answer should be compact. 1. What is the ratio of the Unemployed males (as % of male labor force ages 15-24) of United Arab Emirates in 1996 to that in 1998?
Your answer should be compact. 0.77. What is the ratio of the Unemployed males (as % of male labor force ages 15-24) of East Asia (developing only) in 1996 to that in 1999?
Provide a succinct answer. 0.88. What is the ratio of the Unemployed males (as % of male labor force ages 15-24) of Libya in 1996 to that in 1999?
Your answer should be compact. 1. What is the ratio of the Unemployed males (as % of male labor force ages 15-24) of United Arab Emirates in 1996 to that in 1999?
Provide a succinct answer. 0.75. What is the ratio of the Unemployed males (as % of male labor force ages 15-24) of East Asia (developing only) in 1996 to that in 2000?
Provide a succinct answer. 0.87. What is the ratio of the Unemployed males (as % of male labor force ages 15-24) in Libya in 1996 to that in 2000?
Give a very brief answer. 1. What is the ratio of the Unemployed males (as % of male labor force ages 15-24) of East Asia (developing only) in 1997 to that in 1998?
Offer a terse response. 0.91. What is the ratio of the Unemployed males (as % of male labor force ages 15-24) of United Arab Emirates in 1997 to that in 1998?
Provide a short and direct response. 0.73. What is the ratio of the Unemployed males (as % of male labor force ages 15-24) of East Asia (developing only) in 1997 to that in 1999?
Your response must be concise. 0.91. What is the ratio of the Unemployed males (as % of male labor force ages 15-24) of Libya in 1997 to that in 1999?
Ensure brevity in your answer.  1. What is the ratio of the Unemployed males (as % of male labor force ages 15-24) in United Arab Emirates in 1997 to that in 1999?
Provide a succinct answer. 0.71. What is the ratio of the Unemployed males (as % of male labor force ages 15-24) of East Asia (developing only) in 1997 to that in 2000?
Offer a very short reply. 0.9. What is the ratio of the Unemployed males (as % of male labor force ages 15-24) of Libya in 1997 to that in 2000?
Offer a very short reply. 1. What is the ratio of the Unemployed males (as % of male labor force ages 15-24) of East Asia (developing only) in 1998 to that in 1999?
Give a very brief answer. 0.99. What is the ratio of the Unemployed males (as % of male labor force ages 15-24) in Libya in 1998 to that in 1999?
Your answer should be compact. 1. What is the ratio of the Unemployed males (as % of male labor force ages 15-24) of United Arab Emirates in 1998 to that in 1999?
Your answer should be very brief. 0.97. What is the ratio of the Unemployed males (as % of male labor force ages 15-24) in East Asia (developing only) in 1998 to that in 2000?
Make the answer very short. 0.99. What is the ratio of the Unemployed males (as % of male labor force ages 15-24) in United Arab Emirates in 1998 to that in 2000?
Keep it short and to the point. 1.42. What is the ratio of the Unemployed males (as % of male labor force ages 15-24) in East Asia (developing only) in 1999 to that in 2000?
Keep it short and to the point. 0.99. What is the ratio of the Unemployed males (as % of male labor force ages 15-24) in Libya in 1999 to that in 2000?
Ensure brevity in your answer.  1. What is the ratio of the Unemployed males (as % of male labor force ages 15-24) of United Arab Emirates in 1999 to that in 2000?
Ensure brevity in your answer.  1.46. What is the difference between the highest and the second highest Unemployed males (as % of male labor force ages 15-24) of East Asia (developing only)?
Ensure brevity in your answer.  0.09. What is the difference between the highest and the lowest Unemployed males (as % of male labor force ages 15-24) of East Asia (developing only)?
Your answer should be very brief. 2.09. 